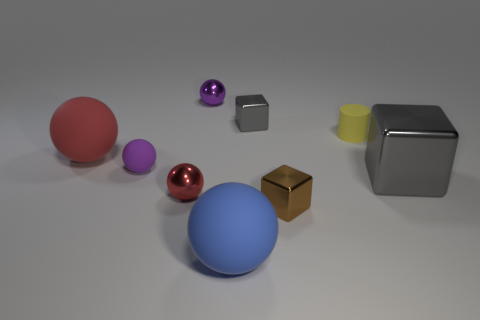How many small cubes have the same color as the big cube?
Give a very brief answer. 1. There is a small rubber thing to the left of the big blue rubber object; is it the same color as the cylinder?
Your response must be concise. No. There is a large thing that is in front of the big cube; what shape is it?
Your answer should be compact. Sphere. Is there a yellow cylinder that is to the left of the small ball behind the large red rubber object?
Give a very brief answer. No. How many things are the same material as the small gray block?
Provide a succinct answer. 4. There is a rubber object right of the big sphere that is right of the large rubber ball left of the blue sphere; how big is it?
Provide a succinct answer. Small. There is a tiny matte cylinder; what number of gray objects are to the right of it?
Your answer should be compact. 1. Are there more large blue spheres than big purple metal cylinders?
Make the answer very short. Yes. There is a block that is the same color as the large metal object; what is its size?
Provide a succinct answer. Small. There is a metallic thing that is both in front of the big gray metal object and to the left of the large blue matte thing; how big is it?
Offer a terse response. Small. 